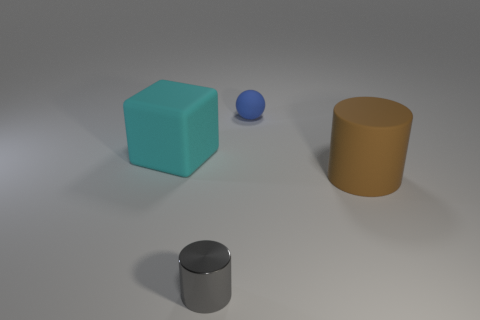Add 1 big blocks. How many objects exist? 5 Subtract all blocks. How many objects are left? 3 Subtract 0 yellow balls. How many objects are left? 4 Subtract all large matte cubes. Subtract all small purple rubber things. How many objects are left? 3 Add 3 tiny gray things. How many tiny gray things are left? 4 Add 4 gray cylinders. How many gray cylinders exist? 5 